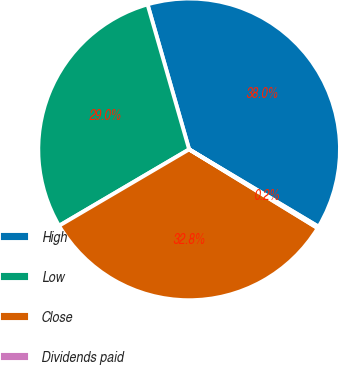Convert chart to OTSL. <chart><loc_0><loc_0><loc_500><loc_500><pie_chart><fcel>High<fcel>Low<fcel>Close<fcel>Dividends paid<nl><fcel>38.02%<fcel>29.01%<fcel>32.8%<fcel>0.18%<nl></chart> 